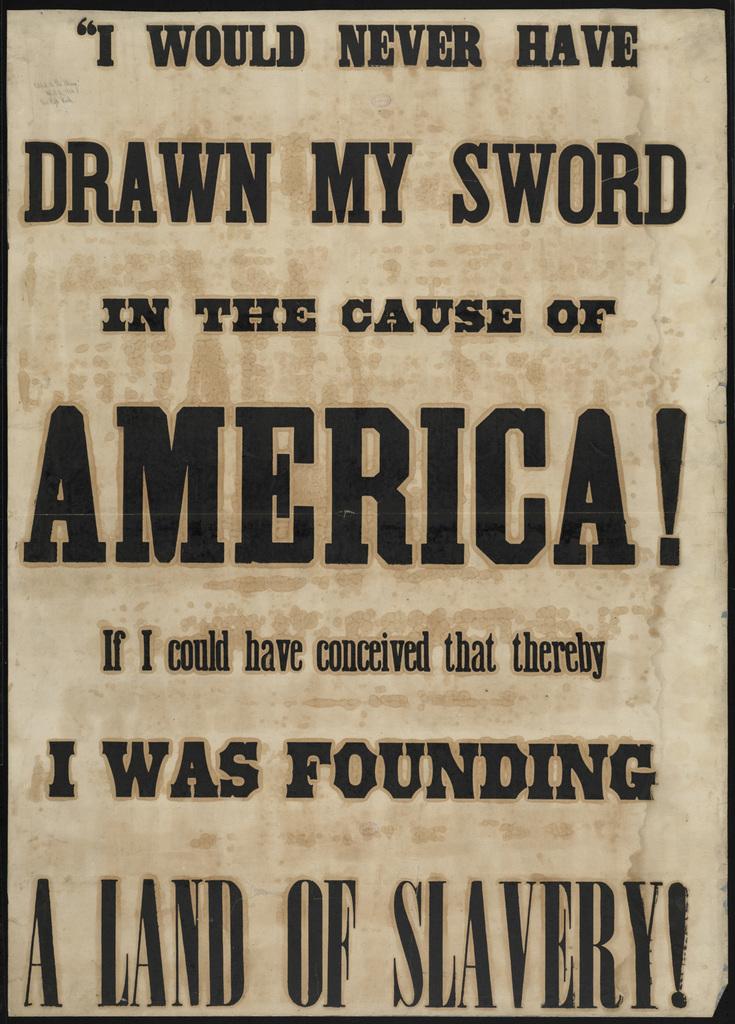Does the author approve of slavery in america?
Provide a succinct answer. No. What would the author never have drawn?
Provide a succinct answer. Sword. 